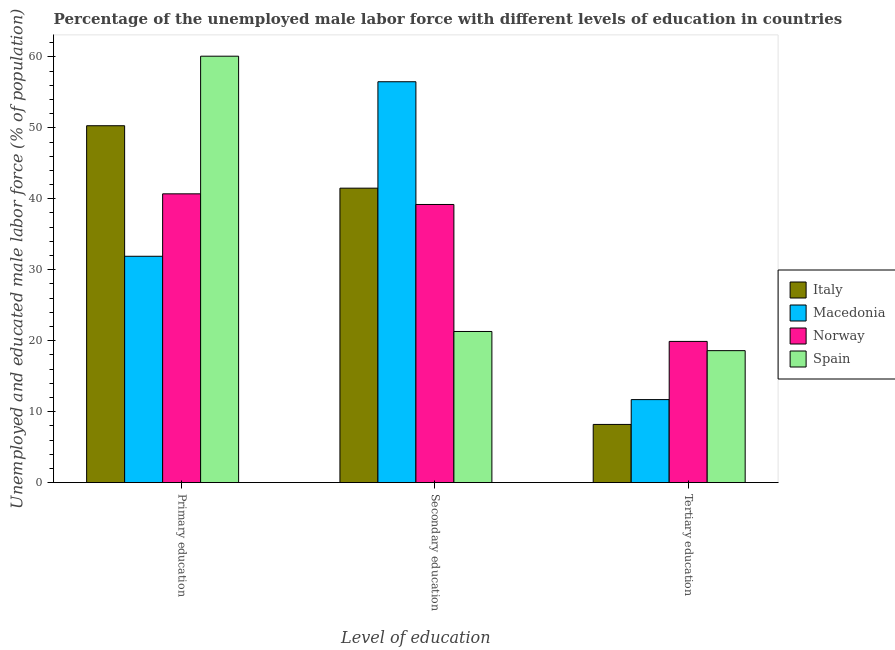How many different coloured bars are there?
Your answer should be very brief. 4. How many groups of bars are there?
Give a very brief answer. 3. Are the number of bars per tick equal to the number of legend labels?
Make the answer very short. Yes. Are the number of bars on each tick of the X-axis equal?
Keep it short and to the point. Yes. How many bars are there on the 1st tick from the left?
Give a very brief answer. 4. What is the percentage of male labor force who received secondary education in Spain?
Give a very brief answer. 21.3. Across all countries, what is the maximum percentage of male labor force who received primary education?
Keep it short and to the point. 60.1. Across all countries, what is the minimum percentage of male labor force who received secondary education?
Offer a very short reply. 21.3. In which country was the percentage of male labor force who received secondary education maximum?
Offer a terse response. Macedonia. In which country was the percentage of male labor force who received tertiary education minimum?
Your answer should be compact. Italy. What is the total percentage of male labor force who received tertiary education in the graph?
Make the answer very short. 58.4. What is the difference between the percentage of male labor force who received secondary education in Norway and that in Spain?
Offer a terse response. 17.9. What is the difference between the percentage of male labor force who received secondary education in Italy and the percentage of male labor force who received primary education in Norway?
Ensure brevity in your answer.  0.8. What is the average percentage of male labor force who received secondary education per country?
Your response must be concise. 39.62. What is the difference between the percentage of male labor force who received tertiary education and percentage of male labor force who received primary education in Italy?
Give a very brief answer. -42.1. In how many countries, is the percentage of male labor force who received primary education greater than 10 %?
Make the answer very short. 4. What is the ratio of the percentage of male labor force who received secondary education in Spain to that in Macedonia?
Make the answer very short. 0.38. Is the percentage of male labor force who received primary education in Norway less than that in Italy?
Offer a very short reply. Yes. What is the difference between the highest and the second highest percentage of male labor force who received tertiary education?
Offer a very short reply. 1.3. What is the difference between the highest and the lowest percentage of male labor force who received tertiary education?
Your answer should be compact. 11.7. In how many countries, is the percentage of male labor force who received tertiary education greater than the average percentage of male labor force who received tertiary education taken over all countries?
Your answer should be very brief. 2. Is the sum of the percentage of male labor force who received tertiary education in Norway and Italy greater than the maximum percentage of male labor force who received secondary education across all countries?
Your answer should be very brief. No. What does the 4th bar from the left in Tertiary education represents?
Keep it short and to the point. Spain. What does the 1st bar from the right in Primary education represents?
Give a very brief answer. Spain. Is it the case that in every country, the sum of the percentage of male labor force who received primary education and percentage of male labor force who received secondary education is greater than the percentage of male labor force who received tertiary education?
Offer a very short reply. Yes. Are all the bars in the graph horizontal?
Ensure brevity in your answer.  No. What is the difference between two consecutive major ticks on the Y-axis?
Your response must be concise. 10. Are the values on the major ticks of Y-axis written in scientific E-notation?
Keep it short and to the point. No. Where does the legend appear in the graph?
Your answer should be compact. Center right. What is the title of the graph?
Offer a very short reply. Percentage of the unemployed male labor force with different levels of education in countries. Does "Middle East & North Africa (developing only)" appear as one of the legend labels in the graph?
Ensure brevity in your answer.  No. What is the label or title of the X-axis?
Provide a succinct answer. Level of education. What is the label or title of the Y-axis?
Give a very brief answer. Unemployed and educated male labor force (% of population). What is the Unemployed and educated male labor force (% of population) of Italy in Primary education?
Offer a terse response. 50.3. What is the Unemployed and educated male labor force (% of population) of Macedonia in Primary education?
Provide a succinct answer. 31.9. What is the Unemployed and educated male labor force (% of population) in Norway in Primary education?
Your answer should be very brief. 40.7. What is the Unemployed and educated male labor force (% of population) in Spain in Primary education?
Make the answer very short. 60.1. What is the Unemployed and educated male labor force (% of population) in Italy in Secondary education?
Ensure brevity in your answer.  41.5. What is the Unemployed and educated male labor force (% of population) of Macedonia in Secondary education?
Make the answer very short. 56.5. What is the Unemployed and educated male labor force (% of population) of Norway in Secondary education?
Give a very brief answer. 39.2. What is the Unemployed and educated male labor force (% of population) in Spain in Secondary education?
Make the answer very short. 21.3. What is the Unemployed and educated male labor force (% of population) in Italy in Tertiary education?
Offer a very short reply. 8.2. What is the Unemployed and educated male labor force (% of population) of Macedonia in Tertiary education?
Ensure brevity in your answer.  11.7. What is the Unemployed and educated male labor force (% of population) in Norway in Tertiary education?
Offer a very short reply. 19.9. What is the Unemployed and educated male labor force (% of population) in Spain in Tertiary education?
Your answer should be compact. 18.6. Across all Level of education, what is the maximum Unemployed and educated male labor force (% of population) in Italy?
Your answer should be compact. 50.3. Across all Level of education, what is the maximum Unemployed and educated male labor force (% of population) in Macedonia?
Offer a very short reply. 56.5. Across all Level of education, what is the maximum Unemployed and educated male labor force (% of population) of Norway?
Offer a terse response. 40.7. Across all Level of education, what is the maximum Unemployed and educated male labor force (% of population) in Spain?
Make the answer very short. 60.1. Across all Level of education, what is the minimum Unemployed and educated male labor force (% of population) of Italy?
Provide a succinct answer. 8.2. Across all Level of education, what is the minimum Unemployed and educated male labor force (% of population) of Macedonia?
Offer a terse response. 11.7. Across all Level of education, what is the minimum Unemployed and educated male labor force (% of population) of Norway?
Your answer should be compact. 19.9. Across all Level of education, what is the minimum Unemployed and educated male labor force (% of population) of Spain?
Your answer should be compact. 18.6. What is the total Unemployed and educated male labor force (% of population) in Italy in the graph?
Your answer should be very brief. 100. What is the total Unemployed and educated male labor force (% of population) in Macedonia in the graph?
Provide a short and direct response. 100.1. What is the total Unemployed and educated male labor force (% of population) of Norway in the graph?
Your answer should be very brief. 99.8. What is the difference between the Unemployed and educated male labor force (% of population) in Macedonia in Primary education and that in Secondary education?
Offer a very short reply. -24.6. What is the difference between the Unemployed and educated male labor force (% of population) of Spain in Primary education and that in Secondary education?
Offer a terse response. 38.8. What is the difference between the Unemployed and educated male labor force (% of population) of Italy in Primary education and that in Tertiary education?
Make the answer very short. 42.1. What is the difference between the Unemployed and educated male labor force (% of population) in Macedonia in Primary education and that in Tertiary education?
Your answer should be very brief. 20.2. What is the difference between the Unemployed and educated male labor force (% of population) of Norway in Primary education and that in Tertiary education?
Make the answer very short. 20.8. What is the difference between the Unemployed and educated male labor force (% of population) of Spain in Primary education and that in Tertiary education?
Make the answer very short. 41.5. What is the difference between the Unemployed and educated male labor force (% of population) of Italy in Secondary education and that in Tertiary education?
Provide a short and direct response. 33.3. What is the difference between the Unemployed and educated male labor force (% of population) of Macedonia in Secondary education and that in Tertiary education?
Your answer should be very brief. 44.8. What is the difference between the Unemployed and educated male labor force (% of population) of Norway in Secondary education and that in Tertiary education?
Make the answer very short. 19.3. What is the difference between the Unemployed and educated male labor force (% of population) of Spain in Secondary education and that in Tertiary education?
Your answer should be very brief. 2.7. What is the difference between the Unemployed and educated male labor force (% of population) in Italy in Primary education and the Unemployed and educated male labor force (% of population) in Macedonia in Secondary education?
Make the answer very short. -6.2. What is the difference between the Unemployed and educated male labor force (% of population) in Italy in Primary education and the Unemployed and educated male labor force (% of population) in Spain in Secondary education?
Your answer should be compact. 29. What is the difference between the Unemployed and educated male labor force (% of population) of Italy in Primary education and the Unemployed and educated male labor force (% of population) of Macedonia in Tertiary education?
Keep it short and to the point. 38.6. What is the difference between the Unemployed and educated male labor force (% of population) in Italy in Primary education and the Unemployed and educated male labor force (% of population) in Norway in Tertiary education?
Your answer should be very brief. 30.4. What is the difference between the Unemployed and educated male labor force (% of population) of Italy in Primary education and the Unemployed and educated male labor force (% of population) of Spain in Tertiary education?
Ensure brevity in your answer.  31.7. What is the difference between the Unemployed and educated male labor force (% of population) of Macedonia in Primary education and the Unemployed and educated male labor force (% of population) of Spain in Tertiary education?
Make the answer very short. 13.3. What is the difference between the Unemployed and educated male labor force (% of population) of Norway in Primary education and the Unemployed and educated male labor force (% of population) of Spain in Tertiary education?
Provide a succinct answer. 22.1. What is the difference between the Unemployed and educated male labor force (% of population) in Italy in Secondary education and the Unemployed and educated male labor force (% of population) in Macedonia in Tertiary education?
Make the answer very short. 29.8. What is the difference between the Unemployed and educated male labor force (% of population) of Italy in Secondary education and the Unemployed and educated male labor force (% of population) of Norway in Tertiary education?
Keep it short and to the point. 21.6. What is the difference between the Unemployed and educated male labor force (% of population) in Italy in Secondary education and the Unemployed and educated male labor force (% of population) in Spain in Tertiary education?
Your response must be concise. 22.9. What is the difference between the Unemployed and educated male labor force (% of population) of Macedonia in Secondary education and the Unemployed and educated male labor force (% of population) of Norway in Tertiary education?
Your response must be concise. 36.6. What is the difference between the Unemployed and educated male labor force (% of population) in Macedonia in Secondary education and the Unemployed and educated male labor force (% of population) in Spain in Tertiary education?
Ensure brevity in your answer.  37.9. What is the difference between the Unemployed and educated male labor force (% of population) of Norway in Secondary education and the Unemployed and educated male labor force (% of population) of Spain in Tertiary education?
Ensure brevity in your answer.  20.6. What is the average Unemployed and educated male labor force (% of population) in Italy per Level of education?
Keep it short and to the point. 33.33. What is the average Unemployed and educated male labor force (% of population) of Macedonia per Level of education?
Provide a succinct answer. 33.37. What is the average Unemployed and educated male labor force (% of population) of Norway per Level of education?
Your answer should be compact. 33.27. What is the average Unemployed and educated male labor force (% of population) of Spain per Level of education?
Your answer should be compact. 33.33. What is the difference between the Unemployed and educated male labor force (% of population) in Macedonia and Unemployed and educated male labor force (% of population) in Norway in Primary education?
Provide a short and direct response. -8.8. What is the difference between the Unemployed and educated male labor force (% of population) in Macedonia and Unemployed and educated male labor force (% of population) in Spain in Primary education?
Offer a very short reply. -28.2. What is the difference between the Unemployed and educated male labor force (% of population) of Norway and Unemployed and educated male labor force (% of population) of Spain in Primary education?
Make the answer very short. -19.4. What is the difference between the Unemployed and educated male labor force (% of population) of Italy and Unemployed and educated male labor force (% of population) of Macedonia in Secondary education?
Offer a terse response. -15. What is the difference between the Unemployed and educated male labor force (% of population) in Italy and Unemployed and educated male labor force (% of population) in Norway in Secondary education?
Offer a terse response. 2.3. What is the difference between the Unemployed and educated male labor force (% of population) in Italy and Unemployed and educated male labor force (% of population) in Spain in Secondary education?
Your response must be concise. 20.2. What is the difference between the Unemployed and educated male labor force (% of population) of Macedonia and Unemployed and educated male labor force (% of population) of Norway in Secondary education?
Provide a succinct answer. 17.3. What is the difference between the Unemployed and educated male labor force (% of population) of Macedonia and Unemployed and educated male labor force (% of population) of Spain in Secondary education?
Your response must be concise. 35.2. What is the difference between the Unemployed and educated male labor force (% of population) of Norway and Unemployed and educated male labor force (% of population) of Spain in Secondary education?
Make the answer very short. 17.9. What is the difference between the Unemployed and educated male labor force (% of population) in Italy and Unemployed and educated male labor force (% of population) in Macedonia in Tertiary education?
Provide a succinct answer. -3.5. What is the difference between the Unemployed and educated male labor force (% of population) of Macedonia and Unemployed and educated male labor force (% of population) of Spain in Tertiary education?
Your response must be concise. -6.9. What is the difference between the Unemployed and educated male labor force (% of population) in Norway and Unemployed and educated male labor force (% of population) in Spain in Tertiary education?
Ensure brevity in your answer.  1.3. What is the ratio of the Unemployed and educated male labor force (% of population) in Italy in Primary education to that in Secondary education?
Make the answer very short. 1.21. What is the ratio of the Unemployed and educated male labor force (% of population) of Macedonia in Primary education to that in Secondary education?
Ensure brevity in your answer.  0.56. What is the ratio of the Unemployed and educated male labor force (% of population) of Norway in Primary education to that in Secondary education?
Your answer should be very brief. 1.04. What is the ratio of the Unemployed and educated male labor force (% of population) of Spain in Primary education to that in Secondary education?
Your response must be concise. 2.82. What is the ratio of the Unemployed and educated male labor force (% of population) of Italy in Primary education to that in Tertiary education?
Provide a succinct answer. 6.13. What is the ratio of the Unemployed and educated male labor force (% of population) of Macedonia in Primary education to that in Tertiary education?
Offer a very short reply. 2.73. What is the ratio of the Unemployed and educated male labor force (% of population) of Norway in Primary education to that in Tertiary education?
Keep it short and to the point. 2.05. What is the ratio of the Unemployed and educated male labor force (% of population) in Spain in Primary education to that in Tertiary education?
Ensure brevity in your answer.  3.23. What is the ratio of the Unemployed and educated male labor force (% of population) in Italy in Secondary education to that in Tertiary education?
Your answer should be compact. 5.06. What is the ratio of the Unemployed and educated male labor force (% of population) of Macedonia in Secondary education to that in Tertiary education?
Give a very brief answer. 4.83. What is the ratio of the Unemployed and educated male labor force (% of population) of Norway in Secondary education to that in Tertiary education?
Your answer should be compact. 1.97. What is the ratio of the Unemployed and educated male labor force (% of population) of Spain in Secondary education to that in Tertiary education?
Provide a short and direct response. 1.15. What is the difference between the highest and the second highest Unemployed and educated male labor force (% of population) of Macedonia?
Your response must be concise. 24.6. What is the difference between the highest and the second highest Unemployed and educated male labor force (% of population) of Norway?
Offer a terse response. 1.5. What is the difference between the highest and the second highest Unemployed and educated male labor force (% of population) of Spain?
Keep it short and to the point. 38.8. What is the difference between the highest and the lowest Unemployed and educated male labor force (% of population) of Italy?
Your response must be concise. 42.1. What is the difference between the highest and the lowest Unemployed and educated male labor force (% of population) of Macedonia?
Keep it short and to the point. 44.8. What is the difference between the highest and the lowest Unemployed and educated male labor force (% of population) of Norway?
Provide a succinct answer. 20.8. What is the difference between the highest and the lowest Unemployed and educated male labor force (% of population) in Spain?
Your response must be concise. 41.5. 